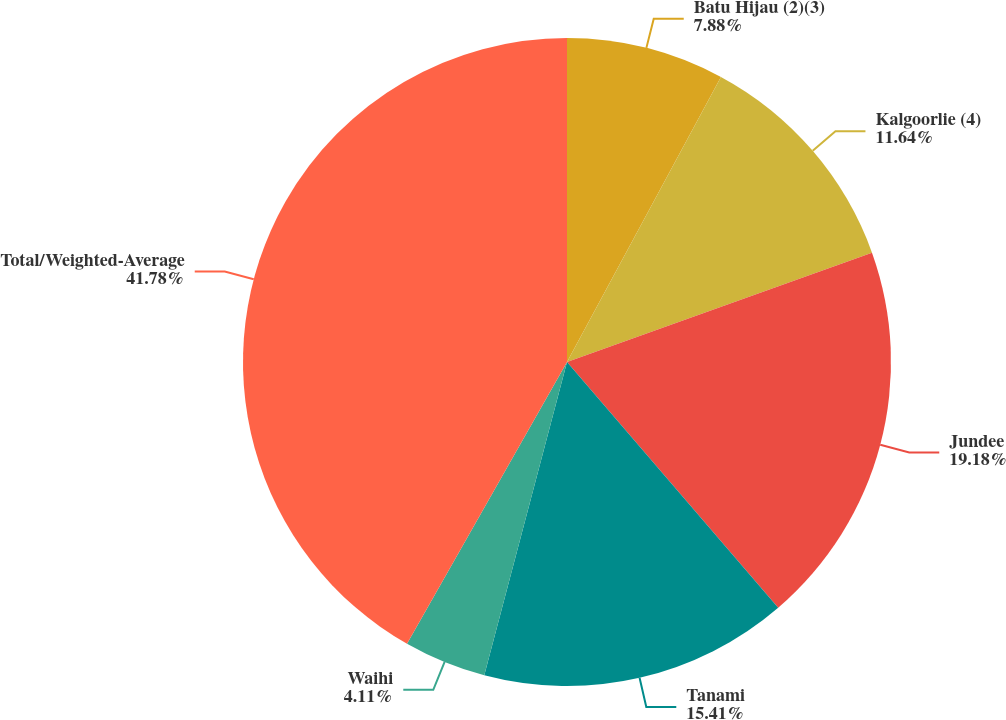Convert chart. <chart><loc_0><loc_0><loc_500><loc_500><pie_chart><fcel>Batu Hijau (2)(3)<fcel>Kalgoorlie (4)<fcel>Jundee<fcel>Tanami<fcel>Waihi<fcel>Total/Weighted-Average<nl><fcel>7.88%<fcel>11.64%<fcel>19.18%<fcel>15.41%<fcel>4.11%<fcel>41.78%<nl></chart> 